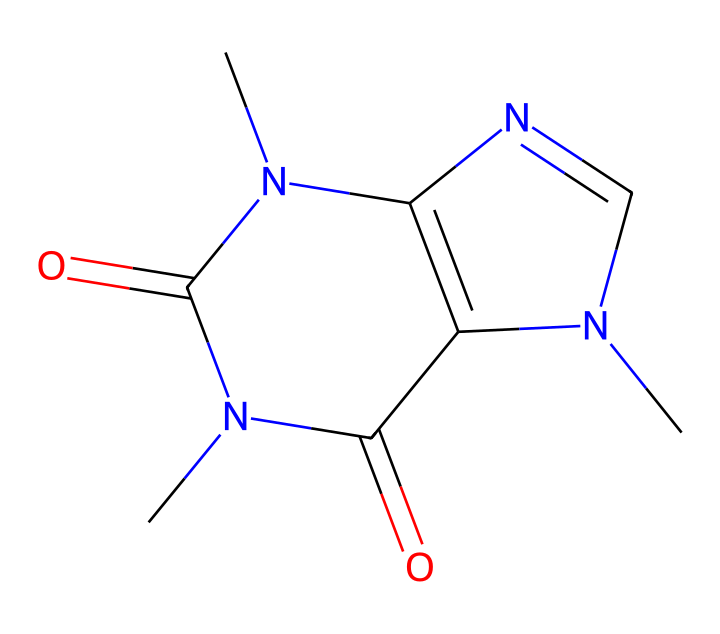What is the molecular formula of caffeine? To determine the molecular formula, we identify the types and quantities of atoms in the structure. From the SMILES representation, we count the carbon (C), hydrogen (H), nitrogen (N), and oxygen (O) atoms, leading us to the molecular formula C8H10N4O2.
Answer: C8H10N4O2 How many nitrogen atoms are present in caffeine? By analyzing the SMILES string, we identify the number of nitrogen (N) atoms present in caffeine's structure. We see four nitrogen atoms as indicated in the representation.
Answer: 4 What functional groups are present in caffeine? Examining the structure, we can see the presence of amine and carbonyl functional groups. The nitrogen atoms indicate amine groups, while the double-bonded oxygen atoms suggest the presence of carbonyls.
Answer: amine and carbonyl What is the total number of rings in the caffeine structure? By inspecting the chemical structure, we see that caffeine contains two fused rings, which are characteristic of its xanthine structure. Thus, the total is two rings.
Answer: 2 What type of compound is caffeine classified as? Based on its structure, which includes nitrogen atoms in a heterocyclic arrangement, caffeine is classified as an alkaloid, a type of nitrogen-containing compound that is often derived from plants.
Answer: alkaloid What is the primary effect of caffeine on the human body? Caffeine primarily functions as a stimulant in the human body, which is due to its ability to block adenosine receptors, therefore increasing alertness and reducing fatigue.
Answer: stimulant 